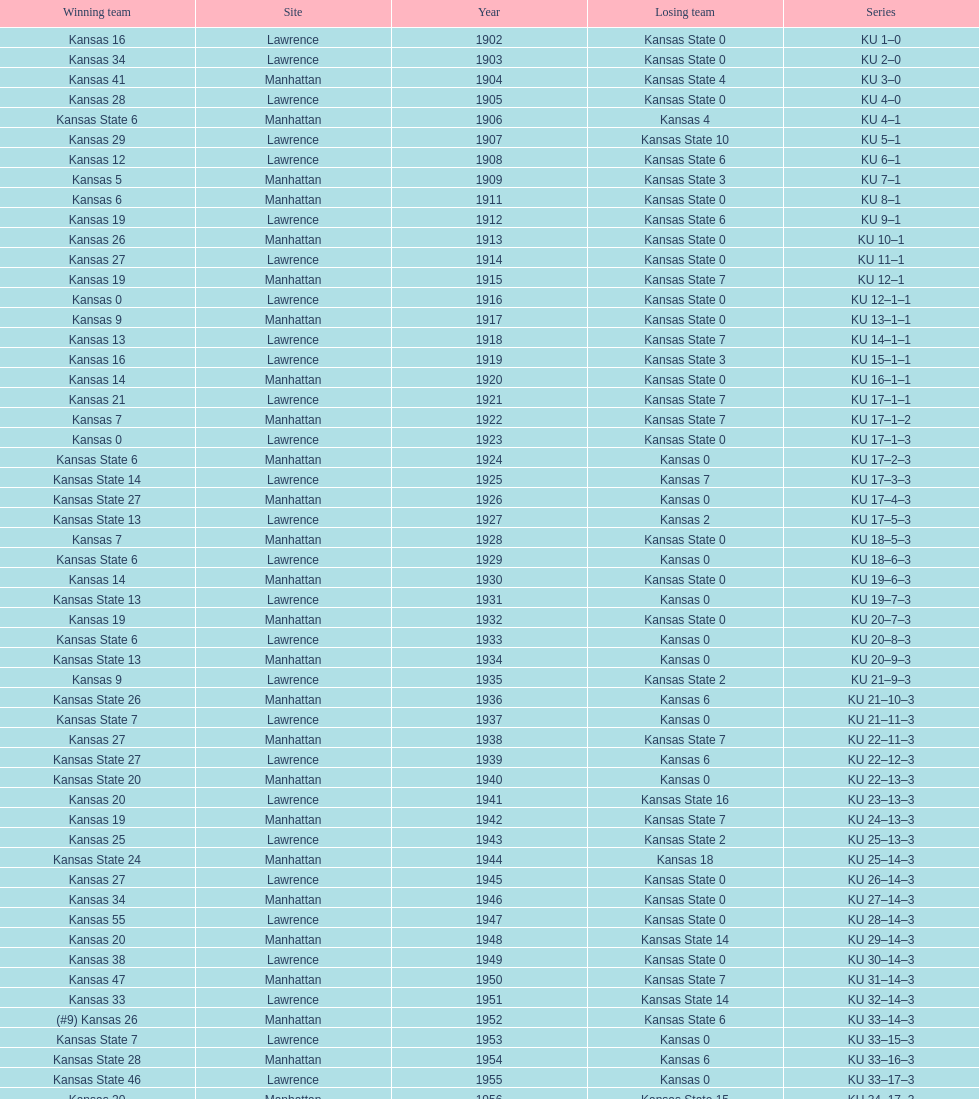How many times did kansas and kansas state play in lawrence from 1902-1968? 34. 